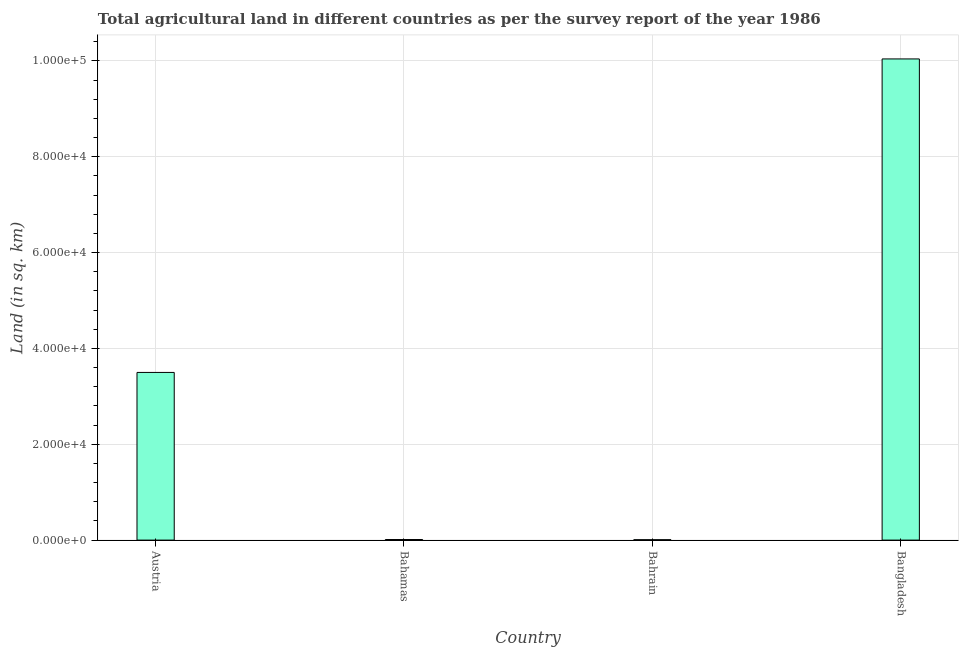Does the graph contain any zero values?
Your answer should be very brief. No. Does the graph contain grids?
Offer a terse response. Yes. What is the title of the graph?
Give a very brief answer. Total agricultural land in different countries as per the survey report of the year 1986. What is the label or title of the Y-axis?
Offer a very short reply. Land (in sq. km). What is the agricultural land in Austria?
Your answer should be compact. 3.50e+04. Across all countries, what is the maximum agricultural land?
Offer a very short reply. 1.00e+05. Across all countries, what is the minimum agricultural land?
Provide a succinct answer. 80. In which country was the agricultural land minimum?
Give a very brief answer. Bahrain. What is the sum of the agricultural land?
Your response must be concise. 1.36e+05. What is the difference between the agricultural land in Austria and Bahrain?
Provide a short and direct response. 3.49e+04. What is the average agricultural land per country?
Ensure brevity in your answer.  3.39e+04. What is the median agricultural land?
Provide a short and direct response. 1.76e+04. In how many countries, is the agricultural land greater than 84000 sq. km?
Provide a short and direct response. 1. Is the difference between the agricultural land in Austria and Bahamas greater than the difference between any two countries?
Ensure brevity in your answer.  No. What is the difference between the highest and the second highest agricultural land?
Your answer should be very brief. 6.54e+04. What is the difference between the highest and the lowest agricultural land?
Provide a succinct answer. 1.00e+05. What is the difference between two consecutive major ticks on the Y-axis?
Provide a succinct answer. 2.00e+04. What is the Land (in sq. km) of Austria?
Keep it short and to the point. 3.50e+04. What is the Land (in sq. km) of Bahamas?
Your answer should be compact. 120. What is the Land (in sq. km) in Bangladesh?
Your response must be concise. 1.00e+05. What is the difference between the Land (in sq. km) in Austria and Bahamas?
Your response must be concise. 3.49e+04. What is the difference between the Land (in sq. km) in Austria and Bahrain?
Make the answer very short. 3.49e+04. What is the difference between the Land (in sq. km) in Austria and Bangladesh?
Your answer should be very brief. -6.54e+04. What is the difference between the Land (in sq. km) in Bahamas and Bahrain?
Your response must be concise. 40. What is the difference between the Land (in sq. km) in Bahamas and Bangladesh?
Your answer should be compact. -1.00e+05. What is the difference between the Land (in sq. km) in Bahrain and Bangladesh?
Provide a short and direct response. -1.00e+05. What is the ratio of the Land (in sq. km) in Austria to that in Bahamas?
Offer a very short reply. 291.58. What is the ratio of the Land (in sq. km) in Austria to that in Bahrain?
Ensure brevity in your answer.  437.38. What is the ratio of the Land (in sq. km) in Austria to that in Bangladesh?
Keep it short and to the point. 0.35. What is the ratio of the Land (in sq. km) in Bahamas to that in Bahrain?
Your answer should be very brief. 1.5. What is the ratio of the Land (in sq. km) in Bahamas to that in Bangladesh?
Your response must be concise. 0. What is the ratio of the Land (in sq. km) in Bahrain to that in Bangladesh?
Offer a terse response. 0. 